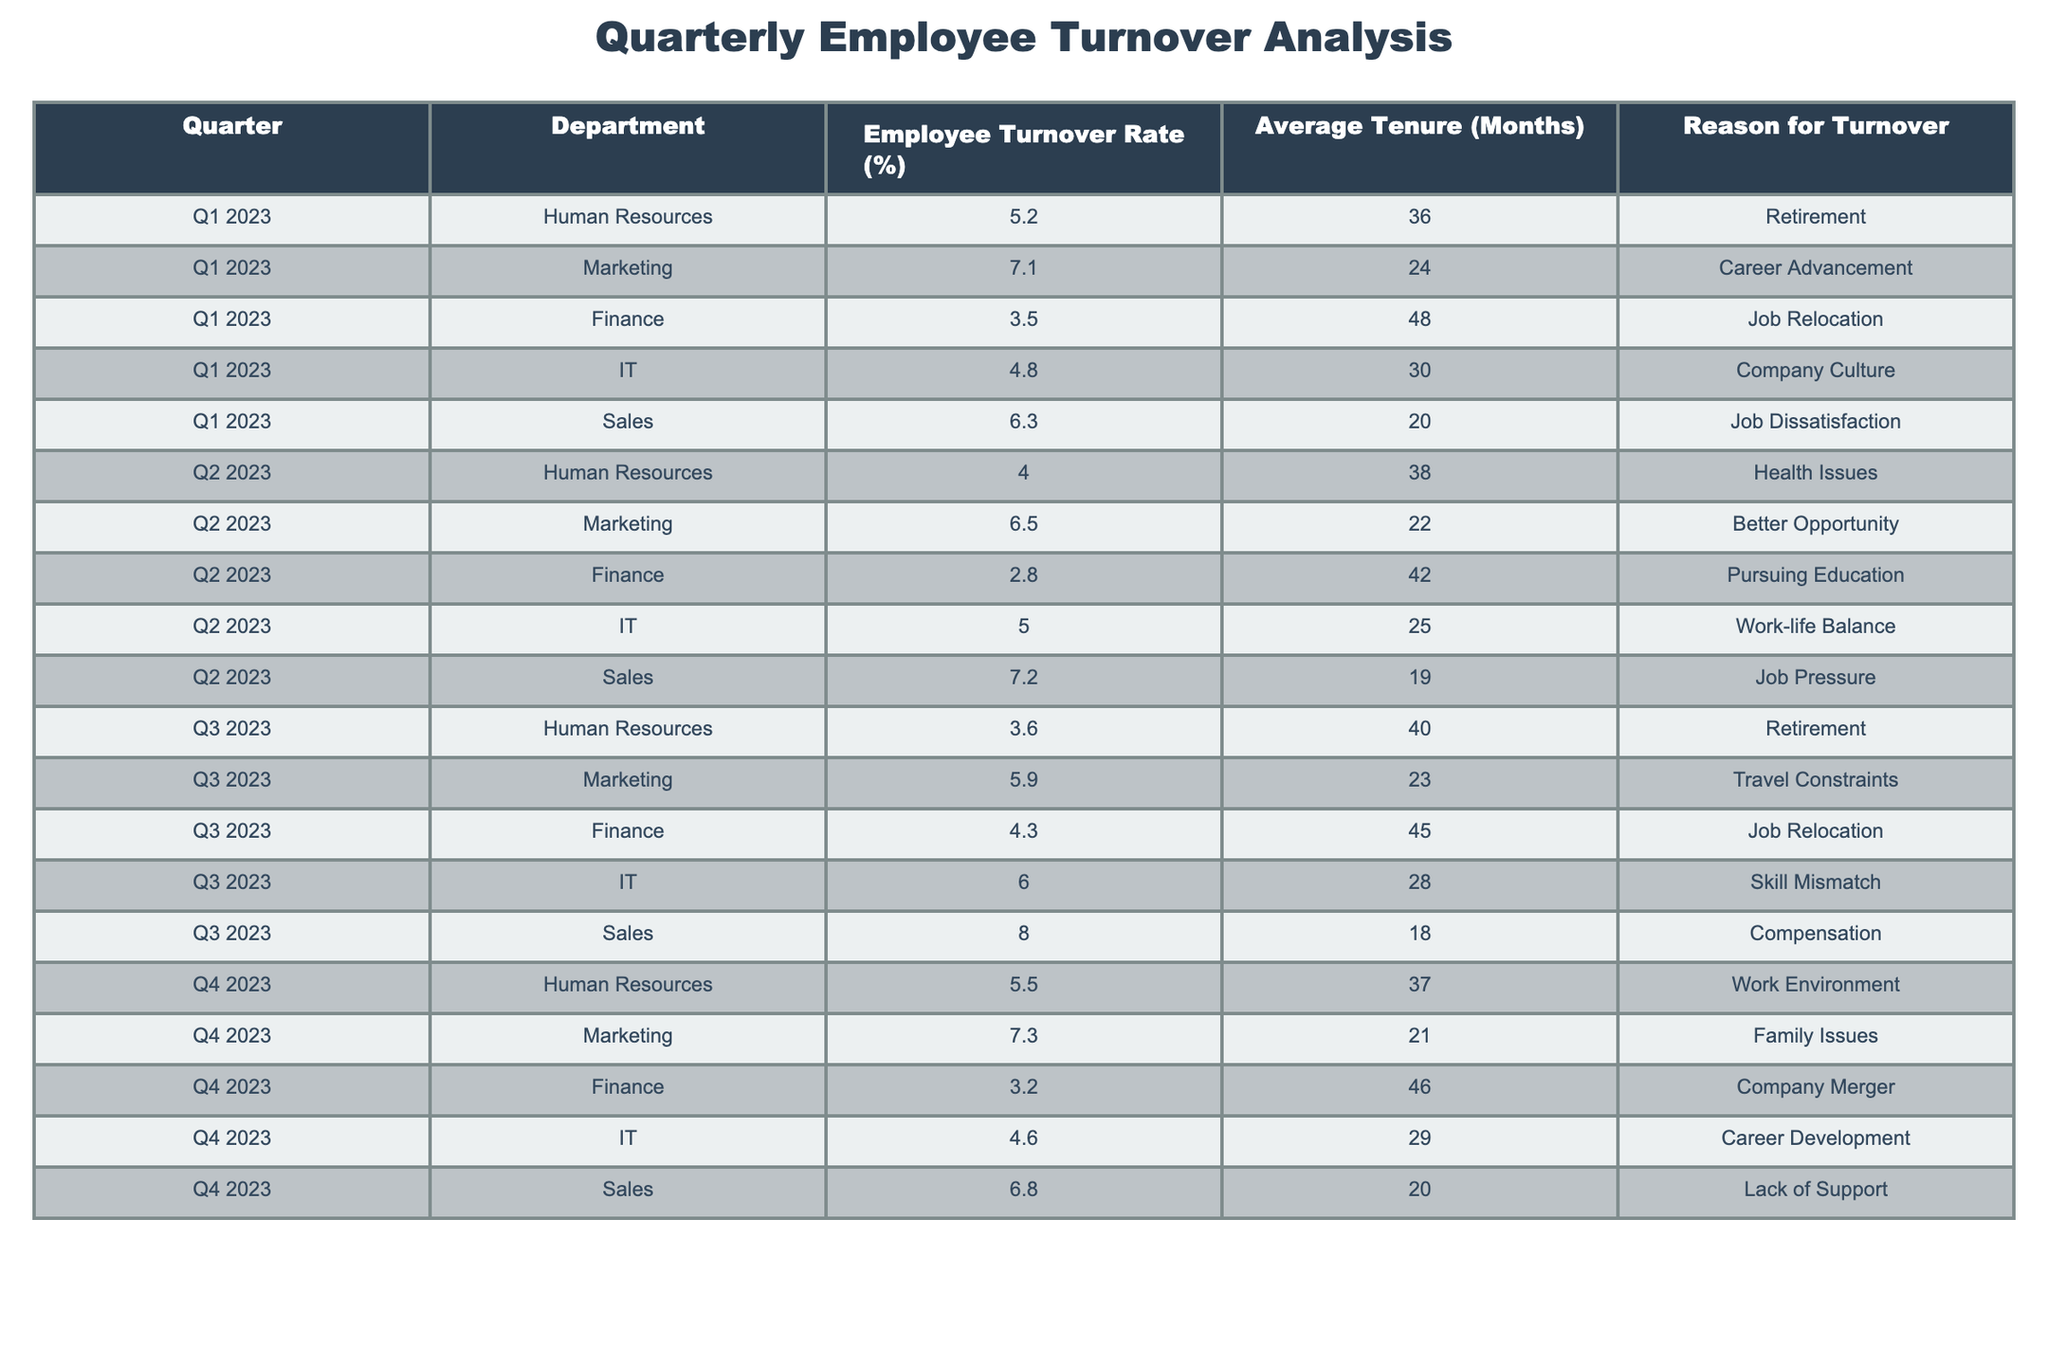What is the employee turnover rate for the IT department in Q3 2023? In Q3 2023, the turnover rate for the IT department is listed directly in the table as 6.0%.
Answer: 6.0% Which department had the highest turnover rate in Q2 2023? By looking at the turnover rates for Q2 2023, the highest rate is for the Sales department with a rate of 7.2%.
Answer: Sales What is the average tenure of employees who left the Marketing department in 2023? The average tenures for the Marketing department in Q1, Q2, and Q3 are 24, 22, and 23 months, respectively. Adding these gives 69 months, and dividing by 3 gives an average of 23 months.
Answer: 23 months Is the turnover rate for Finance in Q4 2023 lower than that in Q3 2023? In Q4 2023, the Finance department has a turnover rate of 3.2%, whereas in Q3 2023, it was 4.3%. Since 3.2% is less than 4.3%, the statement is true.
Answer: Yes What was the total turnover rate across all departments in Q1 2023? Summing the turnover rates in Q1 2023 gives 5.2 + 7.1 + 3.5 + 4.8 + 6.3 = 26.9%. Thus, the total turnover rate is 26.9%.
Answer: 26.9% How does the average turnover rate for Human Resources compare between Q1 and Q4 2023? The turnover rates are 5.2% in Q1 and 5.5% in Q4 2023, respectively. Since 5.5% is greater than 5.2%, the turnover rate increased.
Answer: Increased Which quarter experienced the lowest average turnover rates across all departments? Calculating the average turnover for each quarter, Q1 averages to 5.5%, Q2 to 5.5%, Q3 to 6.0%, and Q4 to 5.2%. The lowest average is in Q4 2023.
Answer: Q4 2023 What is the percentage difference in employee turnover rates for Sales between Q3 and Q4 2023? The turnover for Sales in Q3 is 8.0% and in Q4 is 6.8%. To find the percentage difference: (8.0 - 6.8) / 8.0 * 100 = 15%. Thus, the percentage difference is 15%.
Answer: 15% What was the reason for turnover in Finance in Q2 2023? Referring to the table, the reason for turnover in Finance in Q2 2023 is "Pursuing Education."
Answer: Pursuing Education 